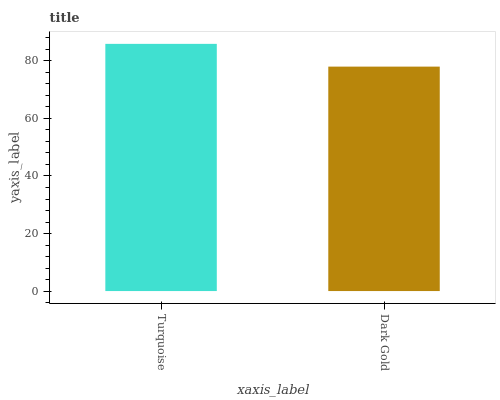Is Dark Gold the maximum?
Answer yes or no. No. Is Turquoise greater than Dark Gold?
Answer yes or no. Yes. Is Dark Gold less than Turquoise?
Answer yes or no. Yes. Is Dark Gold greater than Turquoise?
Answer yes or no. No. Is Turquoise less than Dark Gold?
Answer yes or no. No. Is Turquoise the high median?
Answer yes or no. Yes. Is Dark Gold the low median?
Answer yes or no. Yes. Is Dark Gold the high median?
Answer yes or no. No. Is Turquoise the low median?
Answer yes or no. No. 